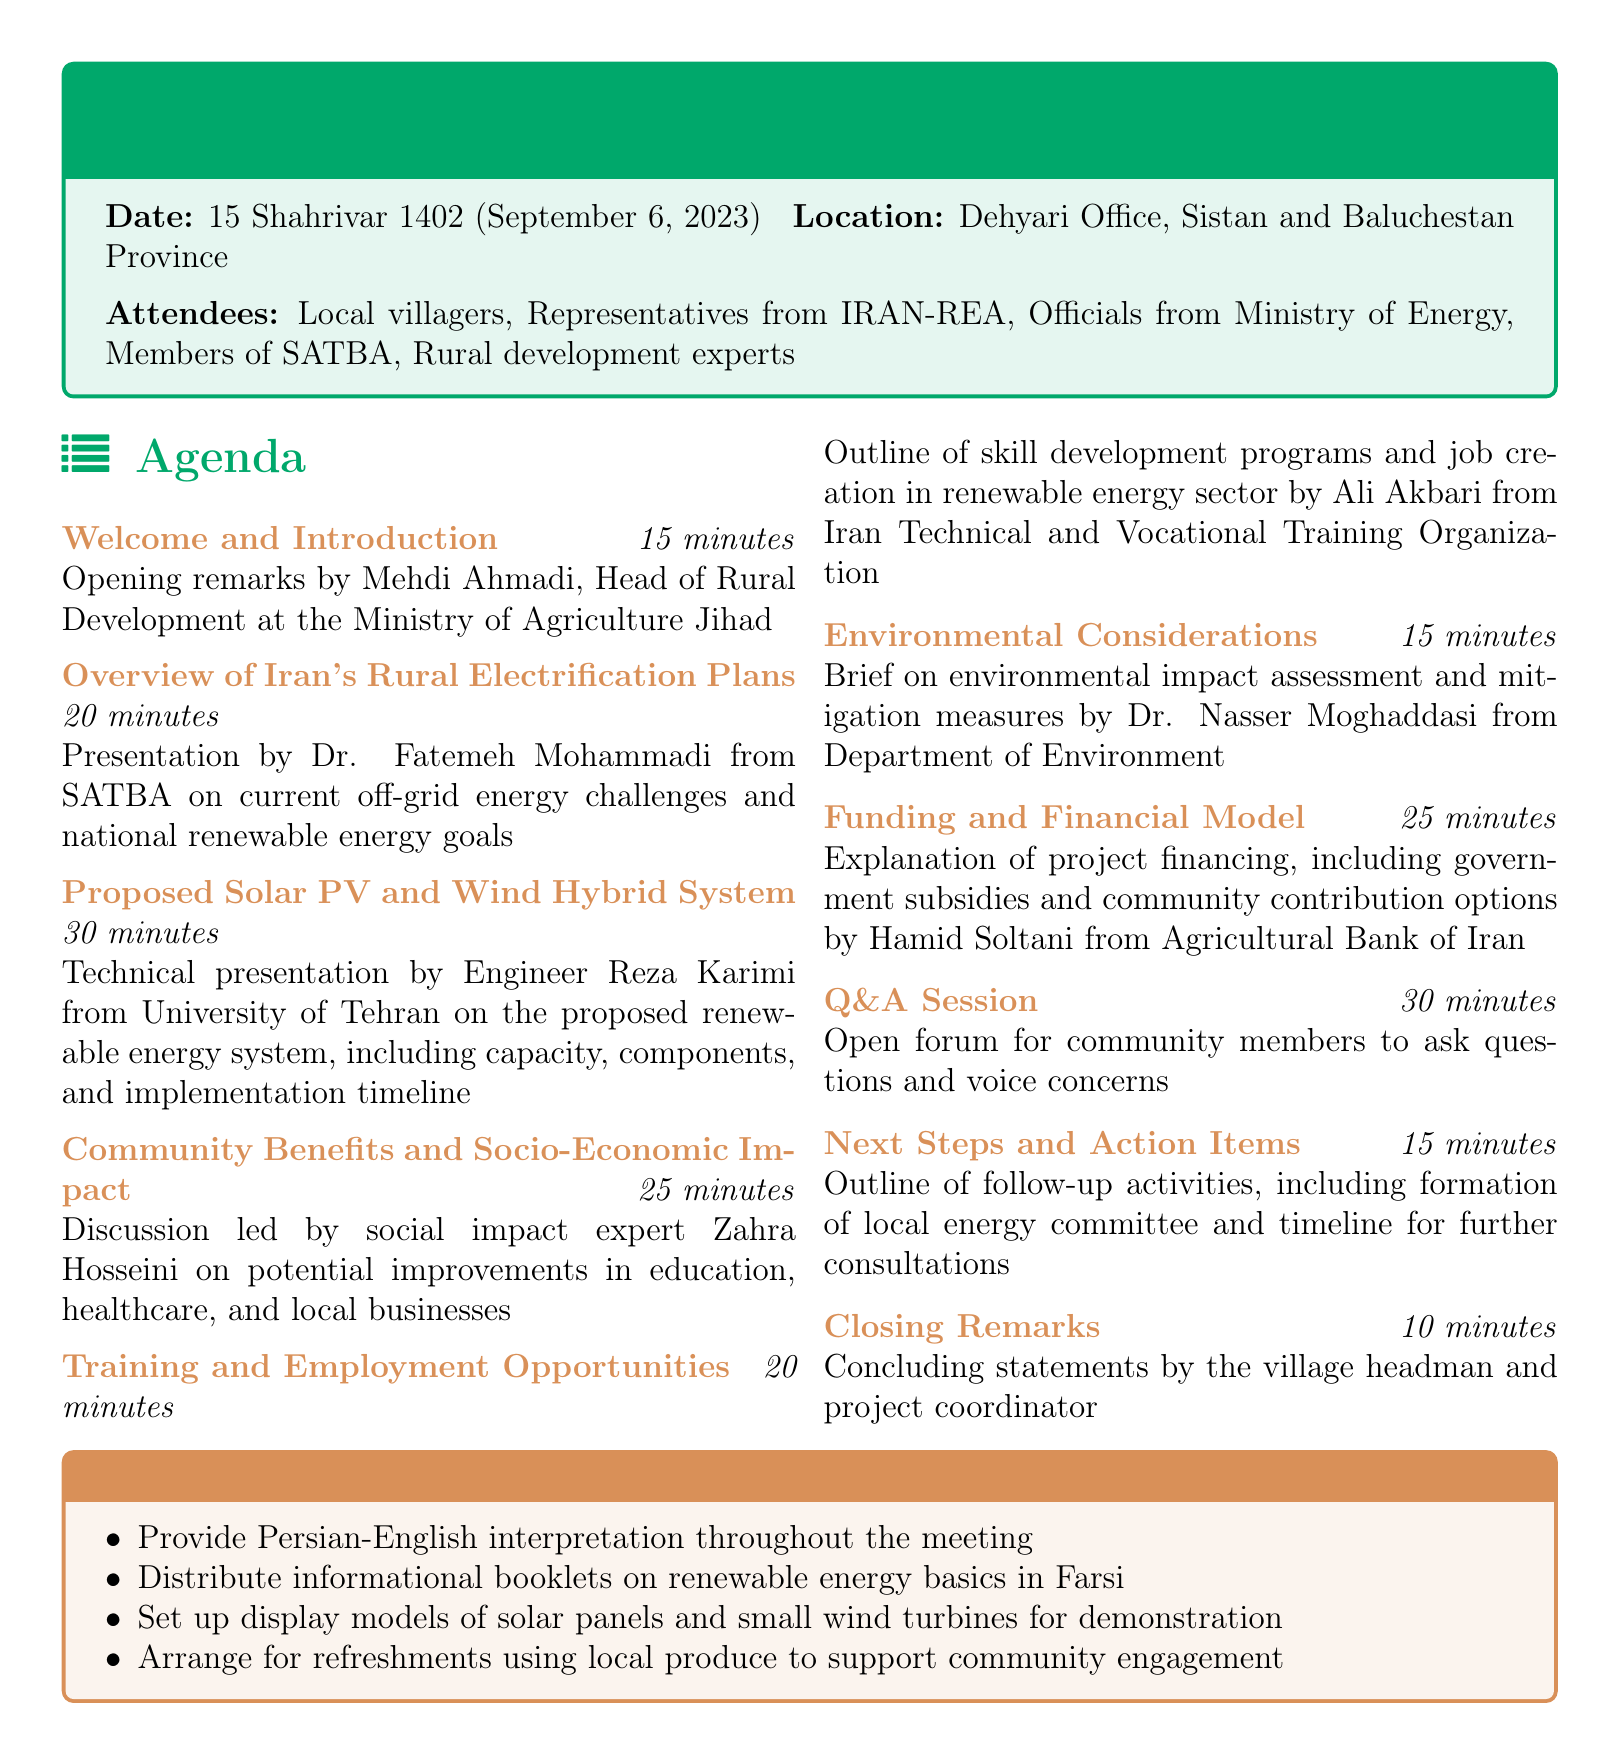What is the date of the meeting? The date of the meeting is specified in the document as 15 Shahrivar 1402, which corresponds to September 6, 2023.
Answer: 15 Shahrivar 1402 (September 6, 2023) Who is presenting on the proposed solar PV and wind hybrid system? The document indicates that Engineer Reza Karimi from the University of Tehran will present this topic.
Answer: Engineer Reza Karimi How long is the Q&A session scheduled for? The duration of the Q&A session is provided in the agenda as 30 minutes.
Answer: 30 minutes What organization is Zahra Hosseini affiliated with? The document states that Zahra Hosseini is a social impact expert leading the discussion on community benefits.
Answer: Not specified Where is the meeting taking place? The location of the meeting is given in the document as Dehyari Office, Sistan and Baluchestan Province.
Answer: Dehyari Office, Sistan and Baluchestan Province What will be distributed at the meeting for information? The agenda notes that informational booklets on renewable energy basics will be distributed.
Answer: Informational booklets on renewable energy basics What is one of the objectives related to local economic improvement? The agenda mentions potential improvements in areas such as education and healthcare, emphasizing socio-economic impact.
Answer: Improvements in education, healthcare, and local businesses Who will provide the interpretation during the meeting? The document specifies that Persian-English interpretation will be provided throughout the meeting.
Answer: Persian-English interpretation What is the total duration for the 'Next Steps and Action Items' section? The document specifies that this section is scheduled for 15 minutes.
Answer: 15 minutes 